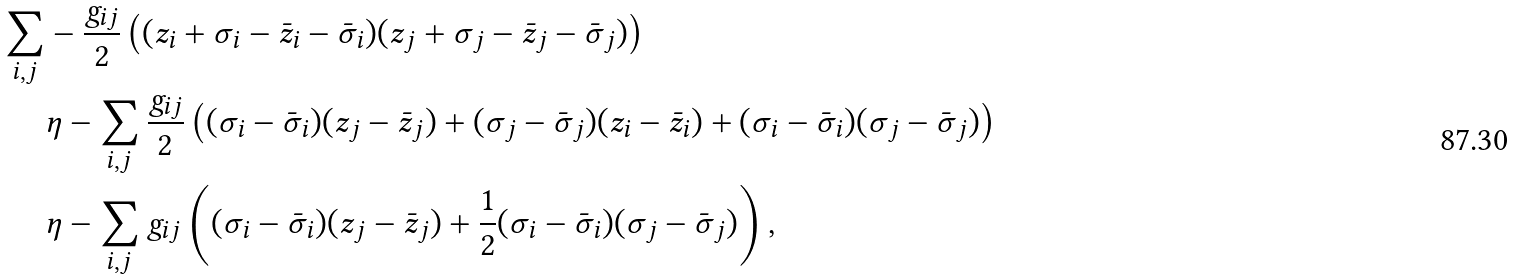<formula> <loc_0><loc_0><loc_500><loc_500>\sum _ { i , j } & - { \frac { g _ { i j } } { 2 } } \left ( ( z _ { i } + \sigma _ { i } - \bar { z } _ { i } - \bar { \sigma } _ { i } ) ( z _ { j } + \sigma _ { j } - \bar { z } _ { j } - \bar { \sigma } _ { j } ) \right ) \\ & \eta - \sum _ { i , j } { \frac { g _ { i j } } { 2 } } \left ( ( \sigma _ { i } - \bar { \sigma } _ { i } ) ( z _ { j } - \bar { z } _ { j } ) + ( \sigma _ { j } - \bar { \sigma } _ { j } ) ( z _ { i } - \bar { z } _ { i } ) + ( \sigma _ { i } - \bar { \sigma } _ { i } ) ( \sigma _ { j } - \bar { \sigma } _ { j } ) \right ) \\ & \eta - \sum _ { i , j } g _ { i j } \left ( ( \sigma _ { i } - \bar { \sigma } _ { i } ) ( z _ { j } - \bar { z } _ { j } ) + { \frac { 1 } { 2 } } ( \sigma _ { i } - \bar { \sigma } _ { i } ) ( \sigma _ { j } - \bar { \sigma } _ { j } ) \right ) ,</formula> 